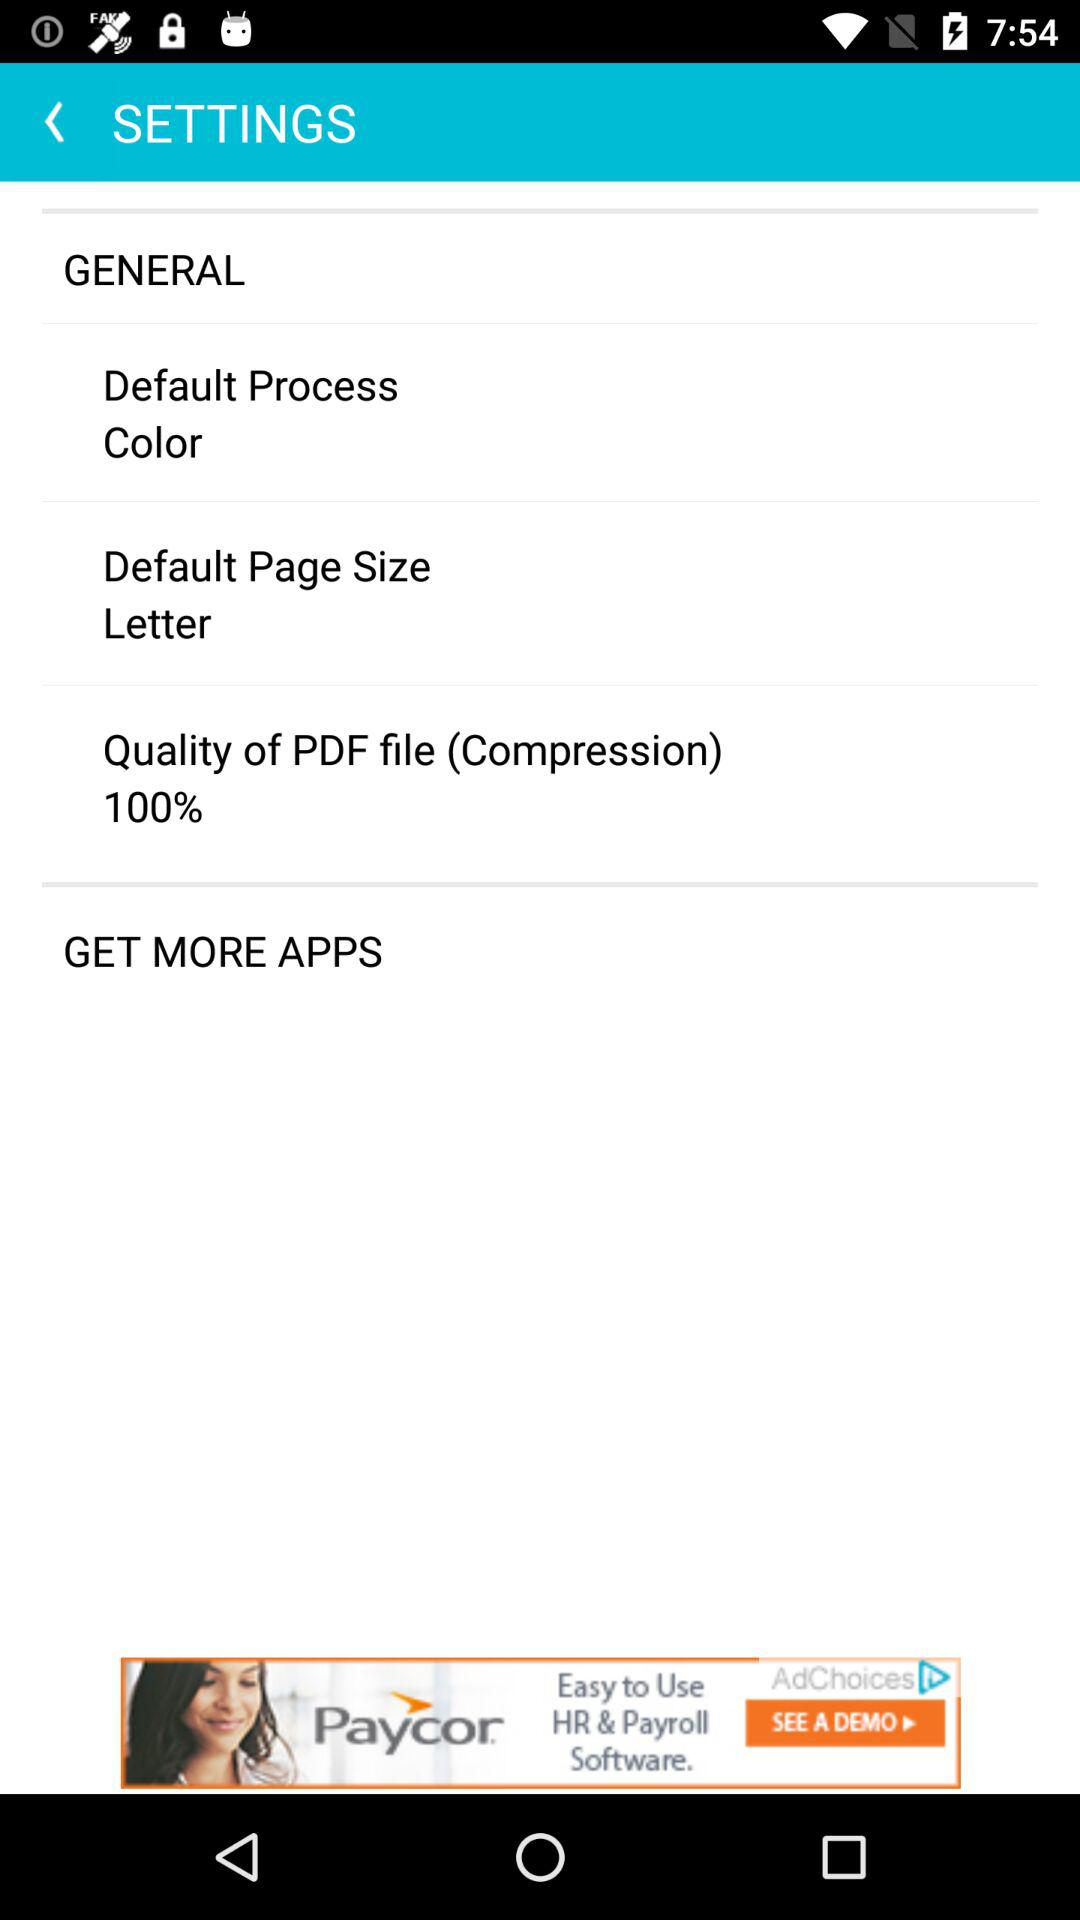What is the default page size? The default page size is letter. 